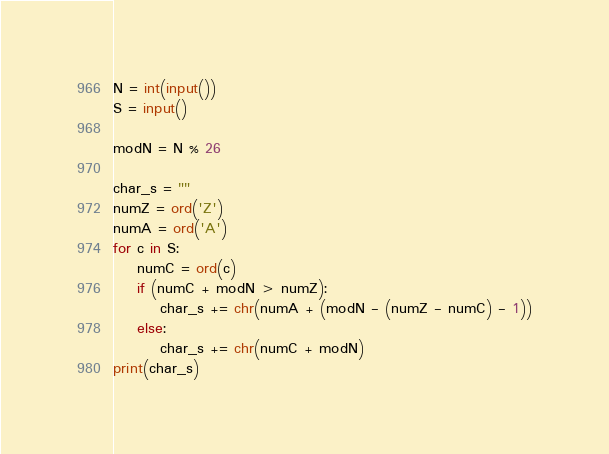<code> <loc_0><loc_0><loc_500><loc_500><_Python_>N = int(input())
S = input()

modN = N % 26

char_s = ""
numZ = ord('Z')
numA = ord('A')
for c in S:
    numC = ord(c)
    if (numC + modN > numZ):
        char_s += chr(numA + (modN - (numZ - numC) - 1))
    else:
        char_s += chr(numC + modN)
print(char_s)</code> 